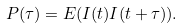<formula> <loc_0><loc_0><loc_500><loc_500>P ( \tau ) = E ( I ( t ) I ( t + \tau ) ) .</formula> 